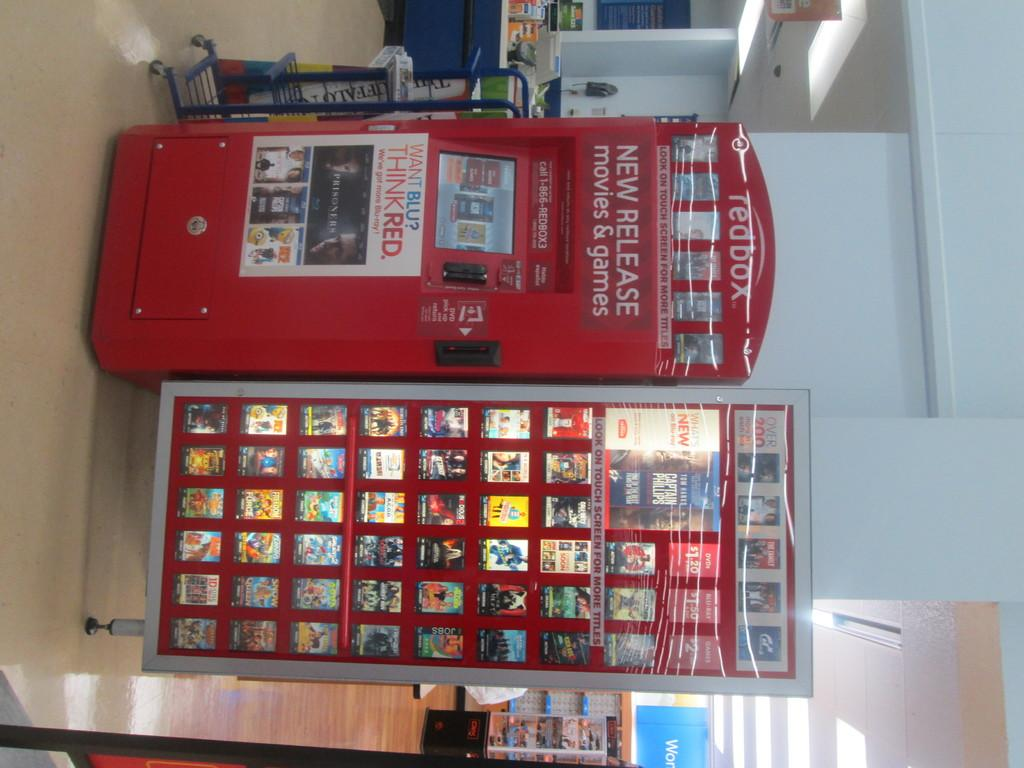<image>
Describe the image concisely. A Red Box vending machine with print telling you the vending box contains new release movies and games. 